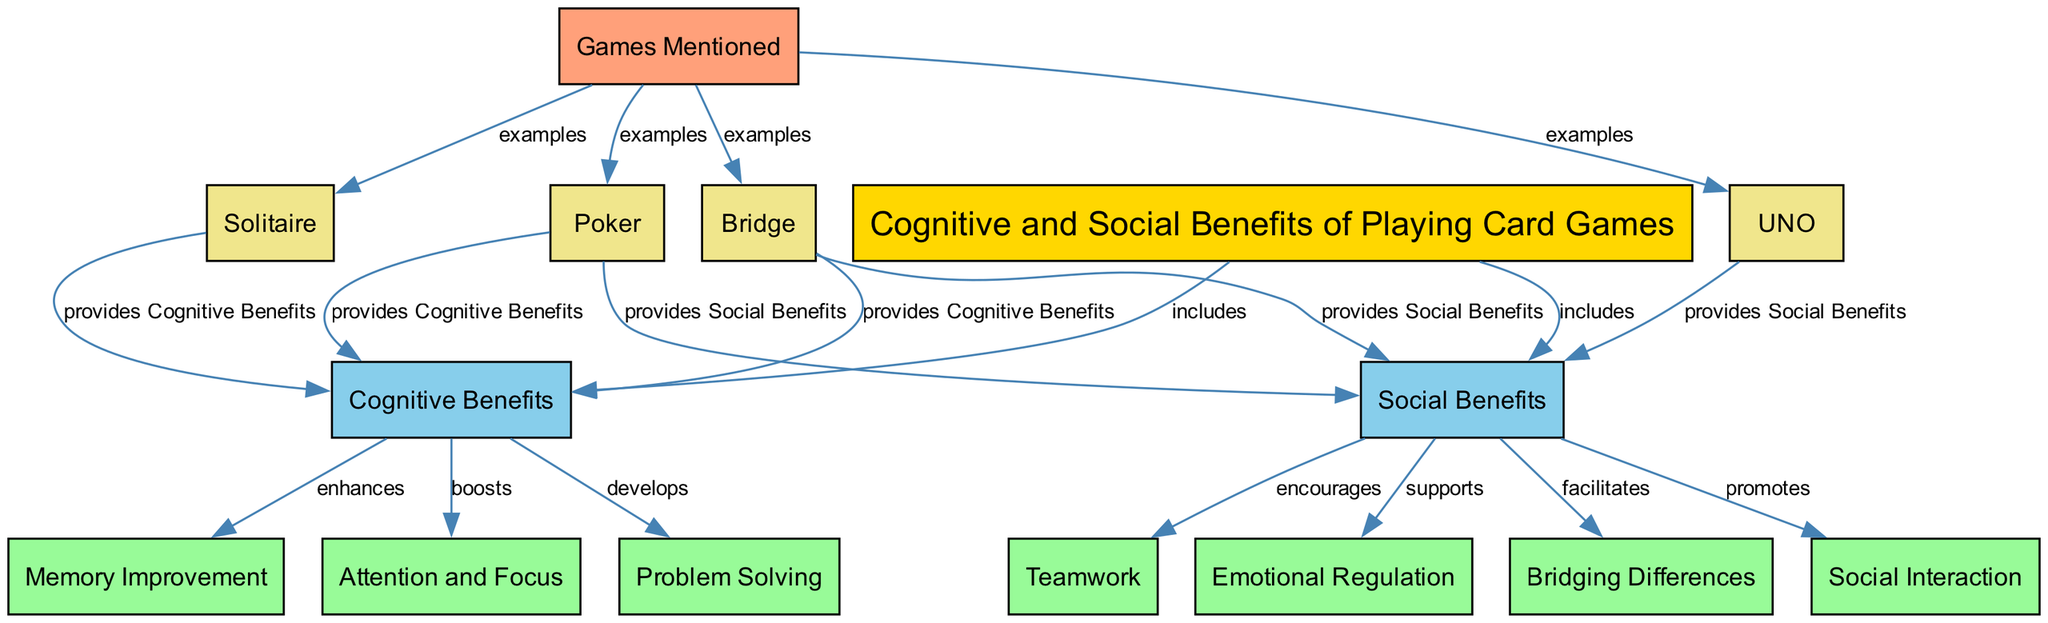What are the two main benefits of playing card games? The diagram indicates that the benefits are categorized into two main groups: "Cognitive Benefits" and "Social Benefits". These categories are directly connected to the main node, "Cognitive and Social Benefits of Playing Card Games".
Answer: Cognitive Benefits and Social Benefits How many cognitive benefits are listed in the diagram? The diagram shows three cognitive benefits: "Memory Improvement," "Attention and Focus," and "Problem Solving." Counting these gives a total of three cognitive benefits.
Answer: 3 What type of relationship exists between "Social Interaction" and "Cognitive and Social Benefits of Playing Card Games"? The label connecting "Social Interaction" to "Cognitive and Social Benefits of Playing Card Games" indicates that "Social Interaction" is included under the broader category of social benefits, establishing a direct connection.
Answer: includes Which game is mentioned as providing both cognitive and social benefits? "Bridge" is specifically connected to both "Cognitive Benefits" and "Social Benefits" in the diagram, indicating that it offers advantages in both dimensions.
Answer: Bridge What do the nodes labeled "Memory Improvement," "Attention and Focus," and "Problem Solving" have in common? All three nodes represent cognitive benefits of playing card games. They are all categorized under the "Cognitive Benefits" category, demonstrating their shared aspect of enhancing cognitive skills.
Answer: Cognitive Benefits How does playing card games facilitate emotional regulation? The diagram shows that "Emotional Regulation" is a shared outcome of engaging in social benefits, specifically connected back to the overall theme of benefits gained through playing card games. This suggests a role of games in improving emotional health.
Answer: Emotional Regulation How many games are mentioned in total? The diagram lists four examples of games: "Poker," "Bridge," "Solitaire," and "UNO." Counting these games yields a total of four different card games mentioned.
Answer: 4 What color represents the cognitive benefits nodes in the diagram? The nodes representing cognitive benefits, including "Memory Improvement," "Attention and Focus," and "Problem Solving," are filled with a light green color (#98FB98) in the diagram.
Answer: light green What does "Bridging Differences" support according to the diagram? The diagram indicates that "Bridging Differences" is categorized under the social benefits, which means it supports interactions that help connect diverse individuals or groups through the medium of card games.
Answer: social benefits 